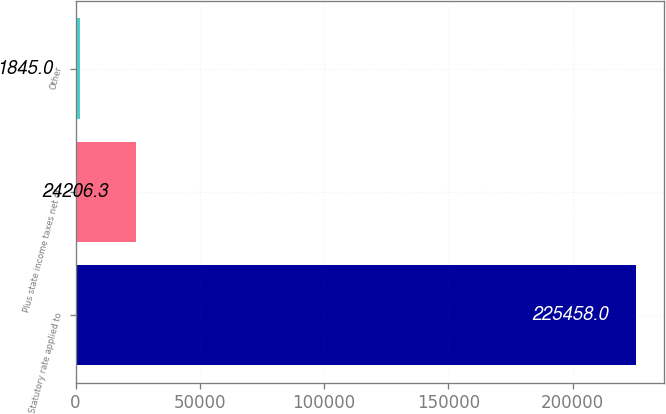<chart> <loc_0><loc_0><loc_500><loc_500><bar_chart><fcel>Statutory rate applied to<fcel>Plus state income taxes net of<fcel>Other<nl><fcel>225458<fcel>24206.3<fcel>1845<nl></chart> 